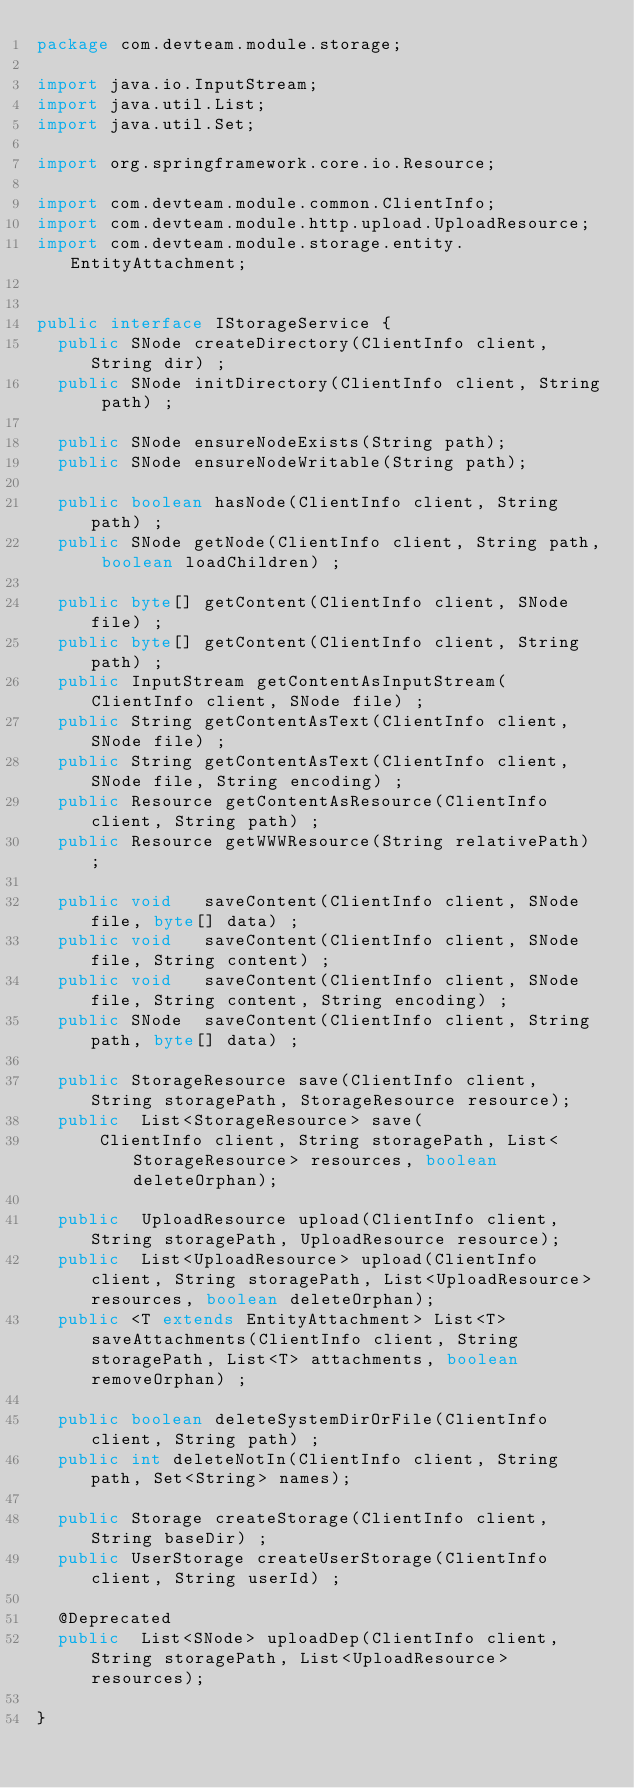<code> <loc_0><loc_0><loc_500><loc_500><_Java_>package com.devteam.module.storage;

import java.io.InputStream;
import java.util.List;
import java.util.Set;

import org.springframework.core.io.Resource;

import com.devteam.module.common.ClientInfo;
import com.devteam.module.http.upload.UploadResource;
import com.devteam.module.storage.entity.EntityAttachment;


public interface IStorageService {
  public SNode createDirectory(ClientInfo client, String dir) ;
  public SNode initDirectory(ClientInfo client, String path) ;

  public SNode ensureNodeExists(String path);
  public SNode ensureNodeWritable(String path);

  public boolean hasNode(ClientInfo client, String path) ;
  public SNode getNode(ClientInfo client, String path, boolean loadChildren) ;

  public byte[] getContent(ClientInfo client, SNode file) ;
  public byte[] getContent(ClientInfo client, String path) ;
  public InputStream getContentAsInputStream(ClientInfo client, SNode file) ;
  public String getContentAsText(ClientInfo client, SNode file) ;
  public String getContentAsText(ClientInfo client, SNode file, String encoding) ;
  public Resource getContentAsResource(ClientInfo client, String path) ;
  public Resource getWWWResource(String relativePath) ;

  public void   saveContent(ClientInfo client, SNode file, byte[] data) ;
  public void   saveContent(ClientInfo client, SNode file, String content) ;
  public void   saveContent(ClientInfo client, SNode file, String content, String encoding) ;
  public SNode  saveContent(ClientInfo client, String path, byte[] data) ;

  public StorageResource save(ClientInfo client, String storagePath, StorageResource resource);
  public  List<StorageResource> save(
      ClientInfo client, String storagePath, List<StorageResource> resources, boolean deleteOrphan);

  public  UploadResource upload(ClientInfo client, String storagePath, UploadResource resource);
  public  List<UploadResource> upload(ClientInfo client, String storagePath, List<UploadResource> resources, boolean deleteOrphan);
  public <T extends EntityAttachment> List<T> saveAttachments(ClientInfo client, String storagePath, List<T> attachments, boolean removeOrphan) ;

  public boolean deleteSystemDirOrFile(ClientInfo client, String path) ;
  public int deleteNotIn(ClientInfo client, String path, Set<String> names);

  public Storage createStorage(ClientInfo client, String baseDir) ;
  public UserStorage createUserStorage(ClientInfo client, String userId) ;

  @Deprecated
  public  List<SNode> uploadDep(ClientInfo client, String storagePath, List<UploadResource> resources);

}

</code> 